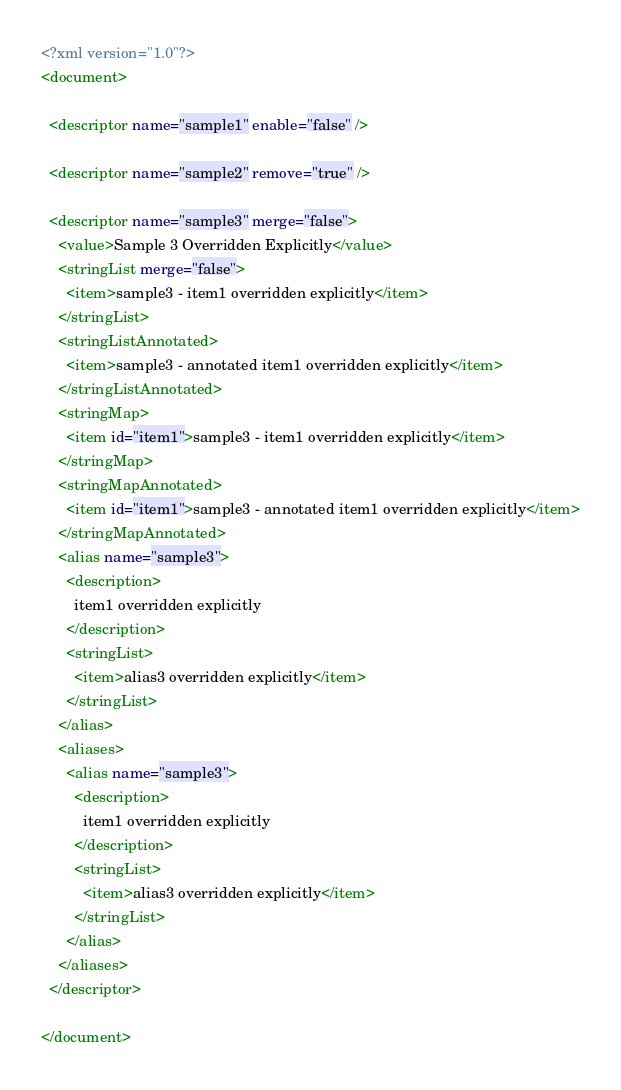Convert code to text. <code><loc_0><loc_0><loc_500><loc_500><_XML_><?xml version="1.0"?>
<document>

  <descriptor name="sample1" enable="false" />

  <descriptor name="sample2" remove="true" />

  <descriptor name="sample3" merge="false">
    <value>Sample 3 Overridden Explicitly</value>
    <stringList merge="false">
      <item>sample3 - item1 overridden explicitly</item>
    </stringList>
    <stringListAnnotated>
      <item>sample3 - annotated item1 overridden explicitly</item>
    </stringListAnnotated>
    <stringMap>
      <item id="item1">sample3 - item1 overridden explicitly</item>
    </stringMap>
    <stringMapAnnotated>
      <item id="item1">sample3 - annotated item1 overridden explicitly</item>
    </stringMapAnnotated>
    <alias name="sample3">
      <description>
        item1 overridden explicitly
      </description>
      <stringList>
        <item>alias3 overridden explicitly</item>
      </stringList>
    </alias>
    <aliases>
      <alias name="sample3">
        <description>
          item1 overridden explicitly
        </description>
        <stringList>
          <item>alias3 overridden explicitly</item>
        </stringList>
      </alias>
    </aliases>
  </descriptor>

</document>
</code> 